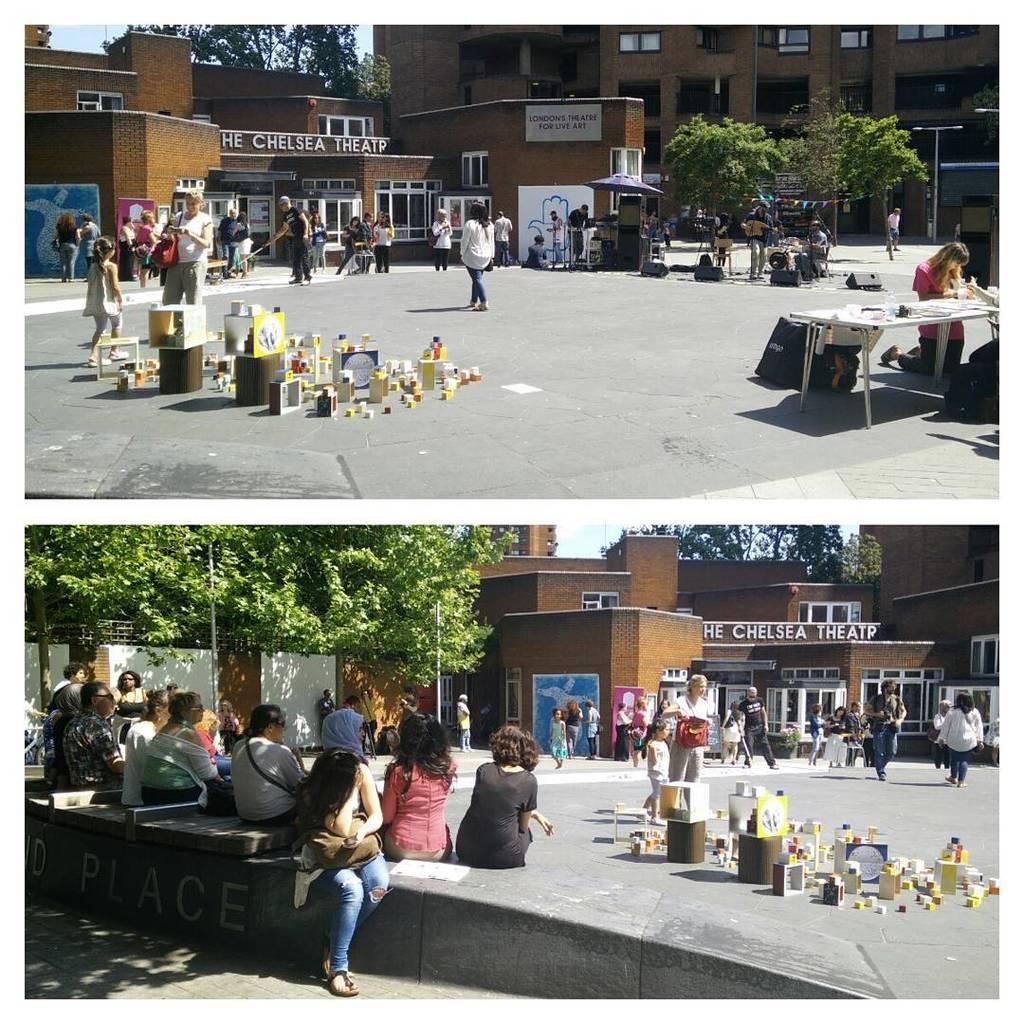Can you describe this image briefly? The image is outside of the city. In the image a group of people standing and walking at bottom we can also see another image in this there are few people are sitting. On right side there are some products and a table. In background we can see some trees,stree light,buildings and sky is on top. 